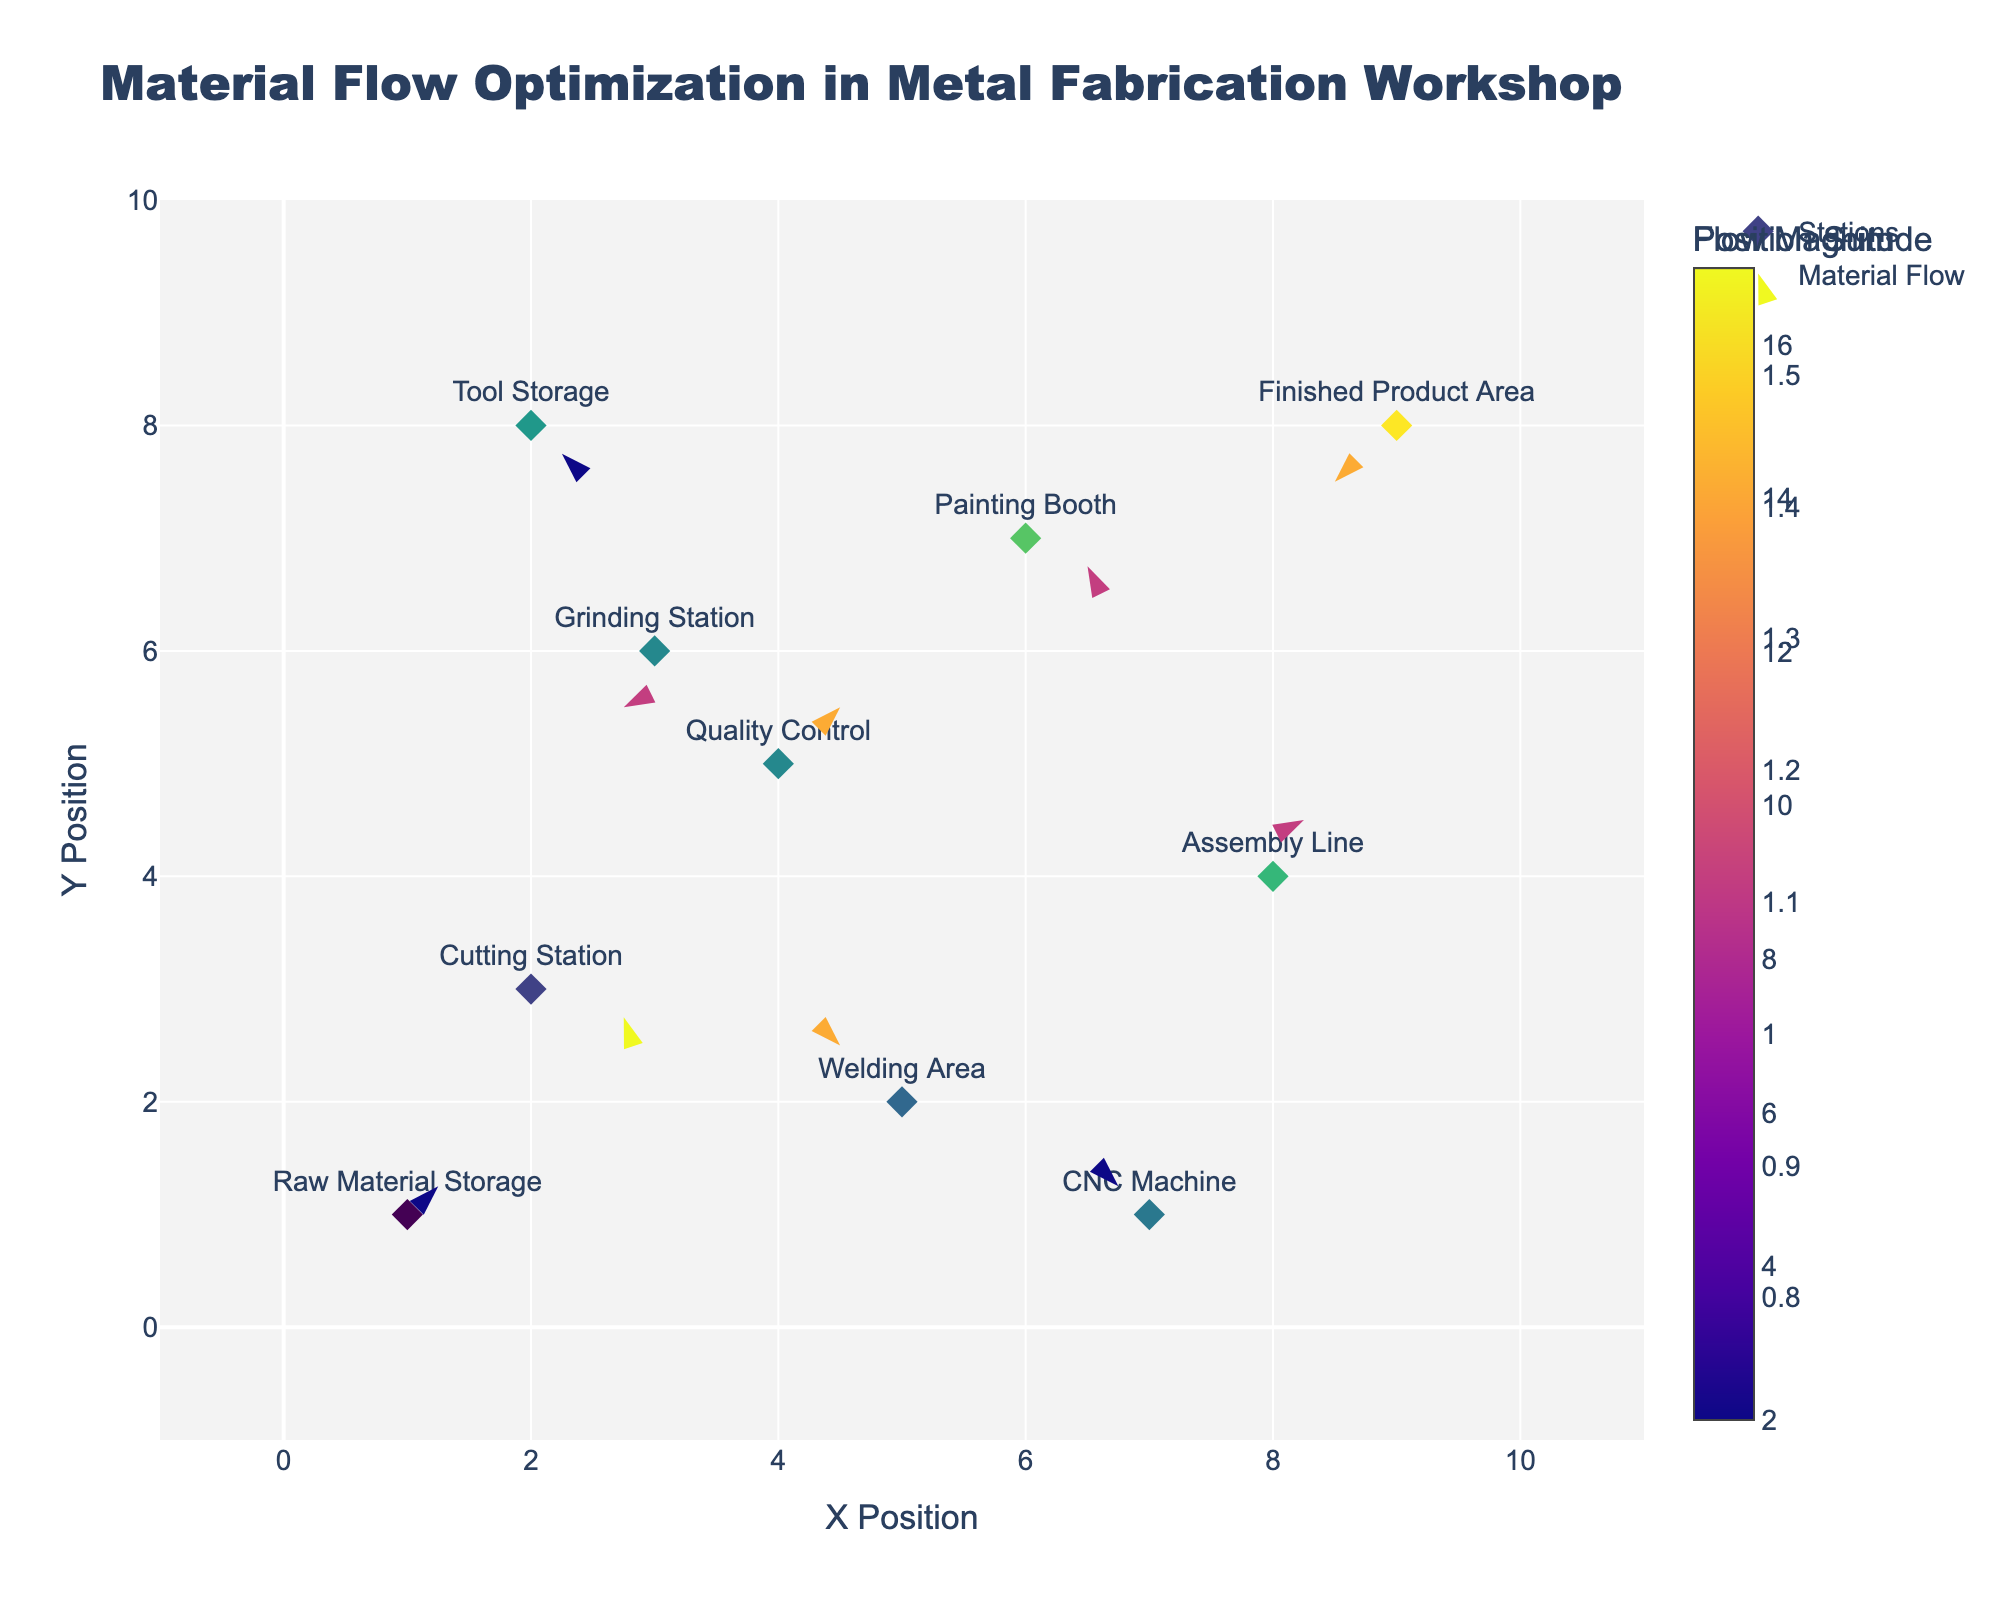What is the title of the figure? The title of the figure is always displayed at the top of the chart in a larger font size.
Answer: Material Flow Optimization in Metal Fabrication Workshop How many stations are marked on the plot? The figure likely marks each station with a diamond symbol, so count all the diamond markers.
Answer: 10 Which station is located at the coordinates (9, 8)? Locate the coordinates (9, 8) on the plot and look at the label next to the diamond marker at that point.
Answer: Finished Product Area What color scale is used to indicate the position sum of X and Y coordinates? Inspect the color scale bar next to the diamond markers; it will show how the sum of X and Y coordinates is represented.
Answer: Viridis Which station has the largest flow magnitude? The flow magnitude can be interpreted by looking at the color of the arrows; inspect the colorbar associated with flow magnitude and identify the station with the darkest or lightest arrow.
Answer: Assembly Line What are the coordinates and vector for the station with the label "Tool Storage"? Identify the "Tool Storage" label and use the plot to determine the surrounding coordinates and the associated vector (U, V). The station's coordinates and vector can be cross-referenced in the data.
Answer: (2, 8), (0.5, -0.5) Which station has an outgoing flow in the negative X and negative Y direction? Determine the direction of the arrows for each station and identify any pointing in both negative X and negative Y directions.
Answer: Grinding Station What's the sum of X and Y coordinates for the Welding Area? Look up the coordinates for the Welding Area in the data or plot, then sum X and Y.
Answer: 7 Which station has the shortest flow vector? The length of the arrow represents the magnitude of the flow vector. Check the arrows and find the shortest one by visual comparison.
Answer: Cutting Station Between the Painting Booth and CNC Machine, which one has a higher flow magnitude? Compare the color intensity of the arrows for Painting Booth and CNC Machine; the more intense color on the flow magnitude scale indicates higher flow.
Answer: Painting Booth 